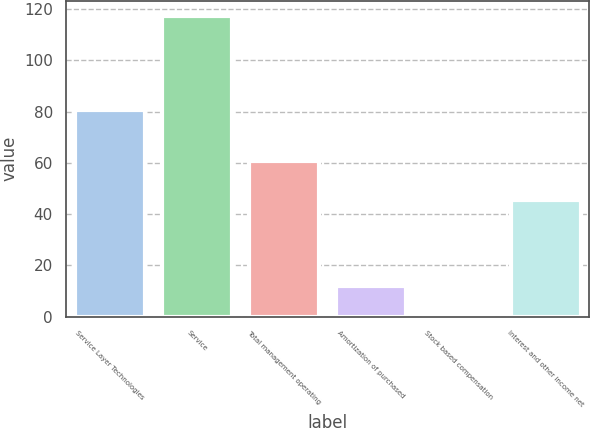Convert chart. <chart><loc_0><loc_0><loc_500><loc_500><bar_chart><fcel>Service Layer Technologies<fcel>Service<fcel>Total management operating<fcel>Amortization of purchased<fcel>Stock based compensation<fcel>Interest and other income net<nl><fcel>80.5<fcel>117.3<fcel>60.7<fcel>12.1<fcel>0.2<fcel>45.5<nl></chart> 